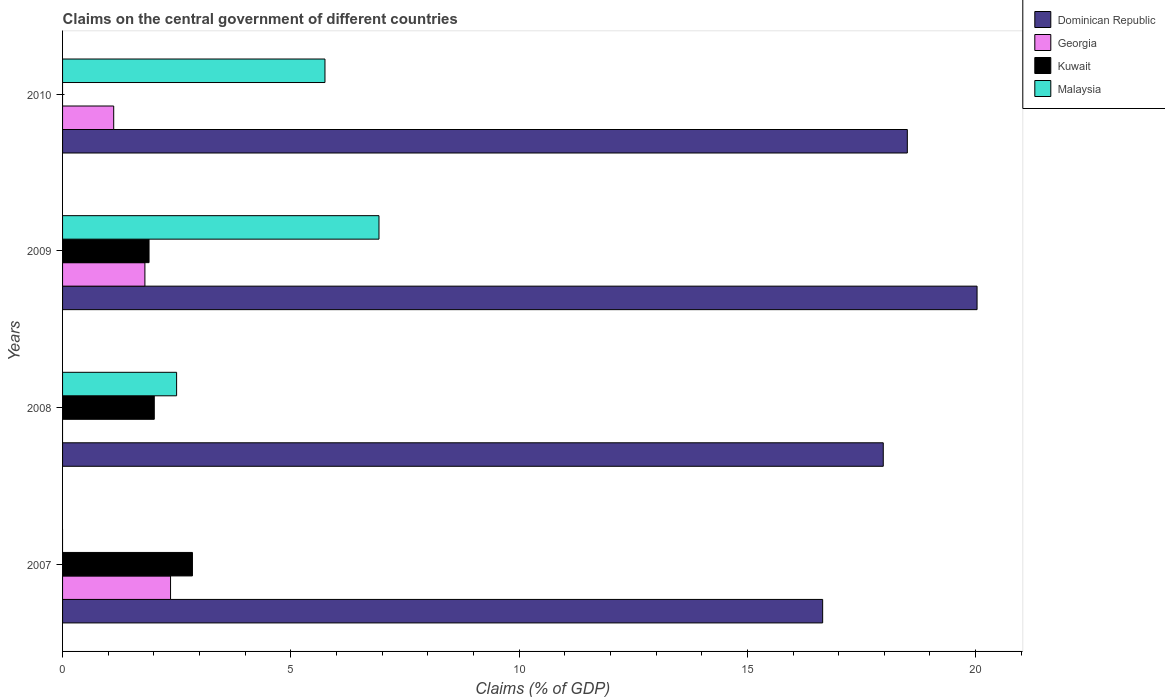How many bars are there on the 2nd tick from the bottom?
Offer a terse response. 3. What is the label of the 1st group of bars from the top?
Keep it short and to the point. 2010. In how many cases, is the number of bars for a given year not equal to the number of legend labels?
Ensure brevity in your answer.  3. What is the percentage of GDP claimed on the central government in Georgia in 2009?
Give a very brief answer. 1.8. Across all years, what is the maximum percentage of GDP claimed on the central government in Georgia?
Ensure brevity in your answer.  2.37. What is the total percentage of GDP claimed on the central government in Georgia in the graph?
Offer a very short reply. 5.29. What is the difference between the percentage of GDP claimed on the central government in Malaysia in 2008 and that in 2009?
Provide a short and direct response. -4.43. What is the difference between the percentage of GDP claimed on the central government in Georgia in 2010 and the percentage of GDP claimed on the central government in Dominican Republic in 2009?
Make the answer very short. -18.91. What is the average percentage of GDP claimed on the central government in Dominican Republic per year?
Ensure brevity in your answer.  18.29. In the year 2009, what is the difference between the percentage of GDP claimed on the central government in Malaysia and percentage of GDP claimed on the central government in Georgia?
Provide a succinct answer. 5.13. What is the ratio of the percentage of GDP claimed on the central government in Dominican Republic in 2009 to that in 2010?
Offer a very short reply. 1.08. Is the percentage of GDP claimed on the central government in Dominican Republic in 2008 less than that in 2009?
Provide a succinct answer. Yes. Is the difference between the percentage of GDP claimed on the central government in Malaysia in 2009 and 2010 greater than the difference between the percentage of GDP claimed on the central government in Georgia in 2009 and 2010?
Make the answer very short. Yes. What is the difference between the highest and the second highest percentage of GDP claimed on the central government in Kuwait?
Make the answer very short. 0.84. What is the difference between the highest and the lowest percentage of GDP claimed on the central government in Kuwait?
Keep it short and to the point. 2.84. In how many years, is the percentage of GDP claimed on the central government in Dominican Republic greater than the average percentage of GDP claimed on the central government in Dominican Republic taken over all years?
Offer a terse response. 2. Is the sum of the percentage of GDP claimed on the central government in Kuwait in 2008 and 2009 greater than the maximum percentage of GDP claimed on the central government in Georgia across all years?
Make the answer very short. Yes. Is it the case that in every year, the sum of the percentage of GDP claimed on the central government in Dominican Republic and percentage of GDP claimed on the central government in Kuwait is greater than the sum of percentage of GDP claimed on the central government in Georgia and percentage of GDP claimed on the central government in Malaysia?
Your answer should be compact. Yes. Is it the case that in every year, the sum of the percentage of GDP claimed on the central government in Kuwait and percentage of GDP claimed on the central government in Georgia is greater than the percentage of GDP claimed on the central government in Dominican Republic?
Make the answer very short. No. How many bars are there?
Keep it short and to the point. 13. How many years are there in the graph?
Your answer should be compact. 4. Are the values on the major ticks of X-axis written in scientific E-notation?
Provide a succinct answer. No. How many legend labels are there?
Provide a short and direct response. 4. How are the legend labels stacked?
Provide a succinct answer. Vertical. What is the title of the graph?
Your answer should be very brief. Claims on the central government of different countries. Does "Yemen, Rep." appear as one of the legend labels in the graph?
Offer a terse response. No. What is the label or title of the X-axis?
Offer a terse response. Claims (% of GDP). What is the label or title of the Y-axis?
Make the answer very short. Years. What is the Claims (% of GDP) of Dominican Republic in 2007?
Provide a short and direct response. 16.65. What is the Claims (% of GDP) of Georgia in 2007?
Offer a terse response. 2.37. What is the Claims (% of GDP) of Kuwait in 2007?
Ensure brevity in your answer.  2.84. What is the Claims (% of GDP) of Dominican Republic in 2008?
Provide a succinct answer. 17.98. What is the Claims (% of GDP) in Georgia in 2008?
Ensure brevity in your answer.  0. What is the Claims (% of GDP) in Kuwait in 2008?
Keep it short and to the point. 2.01. What is the Claims (% of GDP) of Malaysia in 2008?
Provide a succinct answer. 2.5. What is the Claims (% of GDP) in Dominican Republic in 2009?
Provide a succinct answer. 20.03. What is the Claims (% of GDP) of Georgia in 2009?
Offer a very short reply. 1.8. What is the Claims (% of GDP) of Kuwait in 2009?
Ensure brevity in your answer.  1.89. What is the Claims (% of GDP) of Malaysia in 2009?
Keep it short and to the point. 6.93. What is the Claims (% of GDP) in Dominican Republic in 2010?
Keep it short and to the point. 18.5. What is the Claims (% of GDP) of Georgia in 2010?
Your response must be concise. 1.12. What is the Claims (% of GDP) of Malaysia in 2010?
Make the answer very short. 5.75. Across all years, what is the maximum Claims (% of GDP) in Dominican Republic?
Your answer should be compact. 20.03. Across all years, what is the maximum Claims (% of GDP) of Georgia?
Your response must be concise. 2.37. Across all years, what is the maximum Claims (% of GDP) in Kuwait?
Offer a very short reply. 2.84. Across all years, what is the maximum Claims (% of GDP) in Malaysia?
Provide a short and direct response. 6.93. Across all years, what is the minimum Claims (% of GDP) of Dominican Republic?
Provide a short and direct response. 16.65. Across all years, what is the minimum Claims (% of GDP) in Georgia?
Offer a terse response. 0. What is the total Claims (% of GDP) of Dominican Republic in the graph?
Offer a terse response. 73.16. What is the total Claims (% of GDP) of Georgia in the graph?
Your answer should be compact. 5.29. What is the total Claims (% of GDP) of Kuwait in the graph?
Offer a terse response. 6.75. What is the total Claims (% of GDP) in Malaysia in the graph?
Provide a short and direct response. 15.18. What is the difference between the Claims (% of GDP) of Dominican Republic in 2007 and that in 2008?
Make the answer very short. -1.33. What is the difference between the Claims (% of GDP) of Kuwait in 2007 and that in 2008?
Give a very brief answer. 0.84. What is the difference between the Claims (% of GDP) in Dominican Republic in 2007 and that in 2009?
Ensure brevity in your answer.  -3.38. What is the difference between the Claims (% of GDP) of Georgia in 2007 and that in 2009?
Your answer should be very brief. 0.56. What is the difference between the Claims (% of GDP) in Kuwait in 2007 and that in 2009?
Make the answer very short. 0.95. What is the difference between the Claims (% of GDP) of Dominican Republic in 2007 and that in 2010?
Your answer should be compact. -1.85. What is the difference between the Claims (% of GDP) of Georgia in 2007 and that in 2010?
Give a very brief answer. 1.25. What is the difference between the Claims (% of GDP) of Dominican Republic in 2008 and that in 2009?
Your response must be concise. -2.05. What is the difference between the Claims (% of GDP) of Kuwait in 2008 and that in 2009?
Offer a terse response. 0.11. What is the difference between the Claims (% of GDP) of Malaysia in 2008 and that in 2009?
Offer a terse response. -4.43. What is the difference between the Claims (% of GDP) of Dominican Republic in 2008 and that in 2010?
Your answer should be compact. -0.53. What is the difference between the Claims (% of GDP) in Malaysia in 2008 and that in 2010?
Provide a succinct answer. -3.25. What is the difference between the Claims (% of GDP) in Dominican Republic in 2009 and that in 2010?
Ensure brevity in your answer.  1.53. What is the difference between the Claims (% of GDP) in Georgia in 2009 and that in 2010?
Your answer should be compact. 0.68. What is the difference between the Claims (% of GDP) of Malaysia in 2009 and that in 2010?
Your answer should be compact. 1.18. What is the difference between the Claims (% of GDP) of Dominican Republic in 2007 and the Claims (% of GDP) of Kuwait in 2008?
Keep it short and to the point. 14.64. What is the difference between the Claims (% of GDP) in Dominican Republic in 2007 and the Claims (% of GDP) in Malaysia in 2008?
Keep it short and to the point. 14.15. What is the difference between the Claims (% of GDP) in Georgia in 2007 and the Claims (% of GDP) in Kuwait in 2008?
Ensure brevity in your answer.  0.36. What is the difference between the Claims (% of GDP) of Georgia in 2007 and the Claims (% of GDP) of Malaysia in 2008?
Your response must be concise. -0.13. What is the difference between the Claims (% of GDP) of Kuwait in 2007 and the Claims (% of GDP) of Malaysia in 2008?
Provide a succinct answer. 0.35. What is the difference between the Claims (% of GDP) in Dominican Republic in 2007 and the Claims (% of GDP) in Georgia in 2009?
Offer a very short reply. 14.85. What is the difference between the Claims (% of GDP) in Dominican Republic in 2007 and the Claims (% of GDP) in Kuwait in 2009?
Your answer should be compact. 14.76. What is the difference between the Claims (% of GDP) in Dominican Republic in 2007 and the Claims (% of GDP) in Malaysia in 2009?
Provide a succinct answer. 9.72. What is the difference between the Claims (% of GDP) in Georgia in 2007 and the Claims (% of GDP) in Kuwait in 2009?
Offer a very short reply. 0.47. What is the difference between the Claims (% of GDP) of Georgia in 2007 and the Claims (% of GDP) of Malaysia in 2009?
Make the answer very short. -4.57. What is the difference between the Claims (% of GDP) in Kuwait in 2007 and the Claims (% of GDP) in Malaysia in 2009?
Your answer should be very brief. -4.09. What is the difference between the Claims (% of GDP) of Dominican Republic in 2007 and the Claims (% of GDP) of Georgia in 2010?
Keep it short and to the point. 15.53. What is the difference between the Claims (% of GDP) in Dominican Republic in 2007 and the Claims (% of GDP) in Malaysia in 2010?
Provide a short and direct response. 10.9. What is the difference between the Claims (% of GDP) of Georgia in 2007 and the Claims (% of GDP) of Malaysia in 2010?
Ensure brevity in your answer.  -3.38. What is the difference between the Claims (% of GDP) in Kuwait in 2007 and the Claims (% of GDP) in Malaysia in 2010?
Your answer should be very brief. -2.9. What is the difference between the Claims (% of GDP) of Dominican Republic in 2008 and the Claims (% of GDP) of Georgia in 2009?
Offer a terse response. 16.17. What is the difference between the Claims (% of GDP) in Dominican Republic in 2008 and the Claims (% of GDP) in Kuwait in 2009?
Your answer should be very brief. 16.08. What is the difference between the Claims (% of GDP) in Dominican Republic in 2008 and the Claims (% of GDP) in Malaysia in 2009?
Provide a succinct answer. 11.05. What is the difference between the Claims (% of GDP) of Kuwait in 2008 and the Claims (% of GDP) of Malaysia in 2009?
Your response must be concise. -4.92. What is the difference between the Claims (% of GDP) of Dominican Republic in 2008 and the Claims (% of GDP) of Georgia in 2010?
Offer a very short reply. 16.86. What is the difference between the Claims (% of GDP) in Dominican Republic in 2008 and the Claims (% of GDP) in Malaysia in 2010?
Keep it short and to the point. 12.23. What is the difference between the Claims (% of GDP) in Kuwait in 2008 and the Claims (% of GDP) in Malaysia in 2010?
Ensure brevity in your answer.  -3.74. What is the difference between the Claims (% of GDP) in Dominican Republic in 2009 and the Claims (% of GDP) in Georgia in 2010?
Your answer should be very brief. 18.91. What is the difference between the Claims (% of GDP) of Dominican Republic in 2009 and the Claims (% of GDP) of Malaysia in 2010?
Your answer should be very brief. 14.28. What is the difference between the Claims (% of GDP) of Georgia in 2009 and the Claims (% of GDP) of Malaysia in 2010?
Offer a very short reply. -3.94. What is the difference between the Claims (% of GDP) in Kuwait in 2009 and the Claims (% of GDP) in Malaysia in 2010?
Keep it short and to the point. -3.85. What is the average Claims (% of GDP) in Dominican Republic per year?
Your response must be concise. 18.29. What is the average Claims (% of GDP) in Georgia per year?
Keep it short and to the point. 1.32. What is the average Claims (% of GDP) of Kuwait per year?
Offer a very short reply. 1.69. What is the average Claims (% of GDP) in Malaysia per year?
Your answer should be compact. 3.79. In the year 2007, what is the difference between the Claims (% of GDP) in Dominican Republic and Claims (% of GDP) in Georgia?
Your answer should be compact. 14.28. In the year 2007, what is the difference between the Claims (% of GDP) in Dominican Republic and Claims (% of GDP) in Kuwait?
Make the answer very short. 13.8. In the year 2007, what is the difference between the Claims (% of GDP) of Georgia and Claims (% of GDP) of Kuwait?
Provide a short and direct response. -0.48. In the year 2008, what is the difference between the Claims (% of GDP) of Dominican Republic and Claims (% of GDP) of Kuwait?
Offer a very short reply. 15.97. In the year 2008, what is the difference between the Claims (% of GDP) in Dominican Republic and Claims (% of GDP) in Malaysia?
Your response must be concise. 15.48. In the year 2008, what is the difference between the Claims (% of GDP) in Kuwait and Claims (% of GDP) in Malaysia?
Ensure brevity in your answer.  -0.49. In the year 2009, what is the difference between the Claims (% of GDP) in Dominican Republic and Claims (% of GDP) in Georgia?
Provide a succinct answer. 18.23. In the year 2009, what is the difference between the Claims (% of GDP) in Dominican Republic and Claims (% of GDP) in Kuwait?
Offer a terse response. 18.14. In the year 2009, what is the difference between the Claims (% of GDP) in Dominican Republic and Claims (% of GDP) in Malaysia?
Make the answer very short. 13.1. In the year 2009, what is the difference between the Claims (% of GDP) of Georgia and Claims (% of GDP) of Kuwait?
Your response must be concise. -0.09. In the year 2009, what is the difference between the Claims (% of GDP) in Georgia and Claims (% of GDP) in Malaysia?
Offer a very short reply. -5.13. In the year 2009, what is the difference between the Claims (% of GDP) of Kuwait and Claims (% of GDP) of Malaysia?
Your answer should be very brief. -5.04. In the year 2010, what is the difference between the Claims (% of GDP) of Dominican Republic and Claims (% of GDP) of Georgia?
Provide a succinct answer. 17.38. In the year 2010, what is the difference between the Claims (% of GDP) of Dominican Republic and Claims (% of GDP) of Malaysia?
Offer a terse response. 12.76. In the year 2010, what is the difference between the Claims (% of GDP) of Georgia and Claims (% of GDP) of Malaysia?
Offer a terse response. -4.63. What is the ratio of the Claims (% of GDP) of Dominican Republic in 2007 to that in 2008?
Ensure brevity in your answer.  0.93. What is the ratio of the Claims (% of GDP) in Kuwait in 2007 to that in 2008?
Offer a terse response. 1.42. What is the ratio of the Claims (% of GDP) in Dominican Republic in 2007 to that in 2009?
Make the answer very short. 0.83. What is the ratio of the Claims (% of GDP) in Georgia in 2007 to that in 2009?
Make the answer very short. 1.31. What is the ratio of the Claims (% of GDP) of Kuwait in 2007 to that in 2009?
Ensure brevity in your answer.  1.5. What is the ratio of the Claims (% of GDP) of Dominican Republic in 2007 to that in 2010?
Offer a terse response. 0.9. What is the ratio of the Claims (% of GDP) of Georgia in 2007 to that in 2010?
Give a very brief answer. 2.11. What is the ratio of the Claims (% of GDP) in Dominican Republic in 2008 to that in 2009?
Keep it short and to the point. 0.9. What is the ratio of the Claims (% of GDP) of Kuwait in 2008 to that in 2009?
Your response must be concise. 1.06. What is the ratio of the Claims (% of GDP) of Malaysia in 2008 to that in 2009?
Your answer should be very brief. 0.36. What is the ratio of the Claims (% of GDP) of Dominican Republic in 2008 to that in 2010?
Keep it short and to the point. 0.97. What is the ratio of the Claims (% of GDP) of Malaysia in 2008 to that in 2010?
Provide a short and direct response. 0.43. What is the ratio of the Claims (% of GDP) of Dominican Republic in 2009 to that in 2010?
Provide a short and direct response. 1.08. What is the ratio of the Claims (% of GDP) in Georgia in 2009 to that in 2010?
Give a very brief answer. 1.61. What is the ratio of the Claims (% of GDP) of Malaysia in 2009 to that in 2010?
Offer a terse response. 1.21. What is the difference between the highest and the second highest Claims (% of GDP) of Dominican Republic?
Ensure brevity in your answer.  1.53. What is the difference between the highest and the second highest Claims (% of GDP) of Georgia?
Provide a short and direct response. 0.56. What is the difference between the highest and the second highest Claims (% of GDP) in Kuwait?
Your response must be concise. 0.84. What is the difference between the highest and the second highest Claims (% of GDP) of Malaysia?
Ensure brevity in your answer.  1.18. What is the difference between the highest and the lowest Claims (% of GDP) in Dominican Republic?
Your response must be concise. 3.38. What is the difference between the highest and the lowest Claims (% of GDP) of Georgia?
Your answer should be very brief. 2.37. What is the difference between the highest and the lowest Claims (% of GDP) of Kuwait?
Provide a short and direct response. 2.84. What is the difference between the highest and the lowest Claims (% of GDP) in Malaysia?
Your response must be concise. 6.93. 